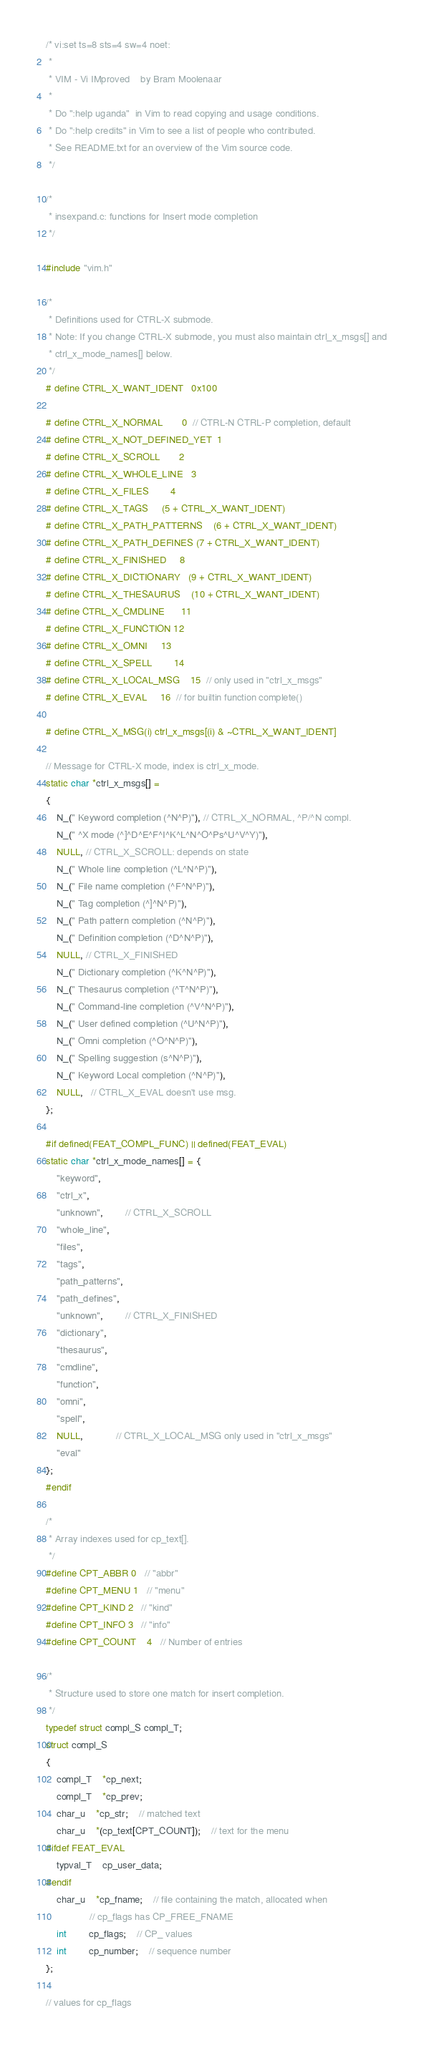<code> <loc_0><loc_0><loc_500><loc_500><_C_>/* vi:set ts=8 sts=4 sw=4 noet:
 *
 * VIM - Vi IMproved	by Bram Moolenaar
 *
 * Do ":help uganda"  in Vim to read copying and usage conditions.
 * Do ":help credits" in Vim to see a list of people who contributed.
 * See README.txt for an overview of the Vim source code.
 */

/*
 * insexpand.c: functions for Insert mode completion
 */

#include "vim.h"

/*
 * Definitions used for CTRL-X submode.
 * Note: If you change CTRL-X submode, you must also maintain ctrl_x_msgs[] and
 * ctrl_x_mode_names[] below.
 */
# define CTRL_X_WANT_IDENT	0x100

# define CTRL_X_NORMAL		0  // CTRL-N CTRL-P completion, default
# define CTRL_X_NOT_DEFINED_YET	1
# define CTRL_X_SCROLL		2
# define CTRL_X_WHOLE_LINE	3
# define CTRL_X_FILES		4
# define CTRL_X_TAGS		(5 + CTRL_X_WANT_IDENT)
# define CTRL_X_PATH_PATTERNS	(6 + CTRL_X_WANT_IDENT)
# define CTRL_X_PATH_DEFINES	(7 + CTRL_X_WANT_IDENT)
# define CTRL_X_FINISHED		8
# define CTRL_X_DICTIONARY	(9 + CTRL_X_WANT_IDENT)
# define CTRL_X_THESAURUS	(10 + CTRL_X_WANT_IDENT)
# define CTRL_X_CMDLINE		11
# define CTRL_X_FUNCTION	12
# define CTRL_X_OMNI		13
# define CTRL_X_SPELL		14
# define CTRL_X_LOCAL_MSG	15	// only used in "ctrl_x_msgs"
# define CTRL_X_EVAL		16	// for builtin function complete()

# define CTRL_X_MSG(i) ctrl_x_msgs[(i) & ~CTRL_X_WANT_IDENT]

// Message for CTRL-X mode, index is ctrl_x_mode.
static char *ctrl_x_msgs[] =
{
    N_(" Keyword completion (^N^P)"), // CTRL_X_NORMAL, ^P/^N compl.
    N_(" ^X mode (^]^D^E^F^I^K^L^N^O^Ps^U^V^Y)"),
    NULL, // CTRL_X_SCROLL: depends on state
    N_(" Whole line completion (^L^N^P)"),
    N_(" File name completion (^F^N^P)"),
    N_(" Tag completion (^]^N^P)"),
    N_(" Path pattern completion (^N^P)"),
    N_(" Definition completion (^D^N^P)"),
    NULL, // CTRL_X_FINISHED
    N_(" Dictionary completion (^K^N^P)"),
    N_(" Thesaurus completion (^T^N^P)"),
    N_(" Command-line completion (^V^N^P)"),
    N_(" User defined completion (^U^N^P)"),
    N_(" Omni completion (^O^N^P)"),
    N_(" Spelling suggestion (s^N^P)"),
    N_(" Keyword Local completion (^N^P)"),
    NULL,   // CTRL_X_EVAL doesn't use msg.
};

#if defined(FEAT_COMPL_FUNC) || defined(FEAT_EVAL)
static char *ctrl_x_mode_names[] = {
	"keyword",
	"ctrl_x",
	"unknown",	    // CTRL_X_SCROLL
	"whole_line",
	"files",
	"tags",
	"path_patterns",
	"path_defines",
	"unknown",	    // CTRL_X_FINISHED
	"dictionary",
	"thesaurus",
	"cmdline",
	"function",
	"omni",
	"spell",
	NULL,		    // CTRL_X_LOCAL_MSG only used in "ctrl_x_msgs"
	"eval"
};
#endif

/*
 * Array indexes used for cp_text[].
 */
#define CPT_ABBR	0	// "abbr"
#define CPT_MENU	1	// "menu"
#define CPT_KIND	2	// "kind"
#define CPT_INFO	3	// "info"
#define CPT_COUNT	4	// Number of entries

/*
 * Structure used to store one match for insert completion.
 */
typedef struct compl_S compl_T;
struct compl_S
{
    compl_T	*cp_next;
    compl_T	*cp_prev;
    char_u	*cp_str;	// matched text
    char_u	*(cp_text[CPT_COUNT]);	// text for the menu
#ifdef FEAT_EVAL
    typval_T	cp_user_data;
#endif
    char_u	*cp_fname;	// file containing the match, allocated when
				// cp_flags has CP_FREE_FNAME
    int		cp_flags;	// CP_ values
    int		cp_number;	// sequence number
};

// values for cp_flags</code> 